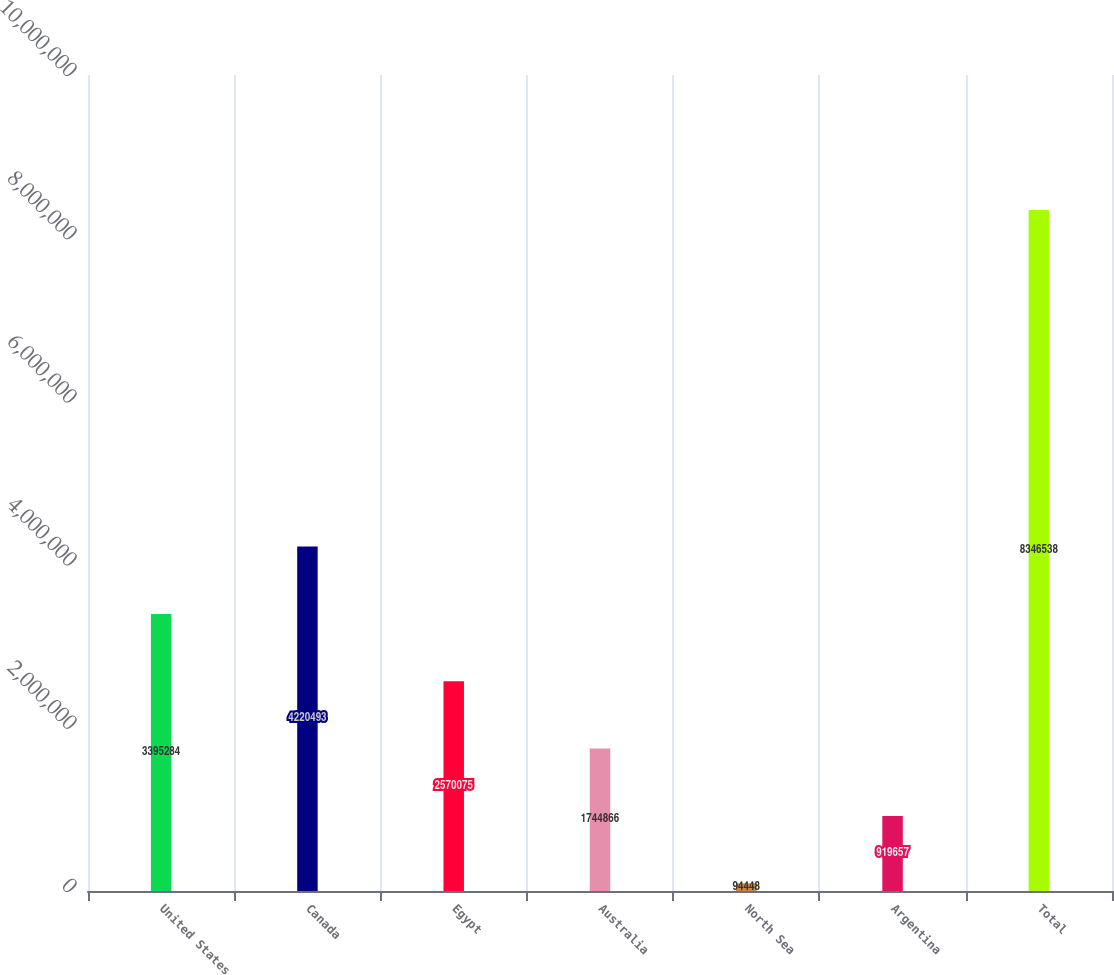Convert chart to OTSL. <chart><loc_0><loc_0><loc_500><loc_500><bar_chart><fcel>United States<fcel>Canada<fcel>Egypt<fcel>Australia<fcel>North Sea<fcel>Argentina<fcel>Total<nl><fcel>3.39528e+06<fcel>4.22049e+06<fcel>2.57008e+06<fcel>1.74487e+06<fcel>94448<fcel>919657<fcel>8.34654e+06<nl></chart> 